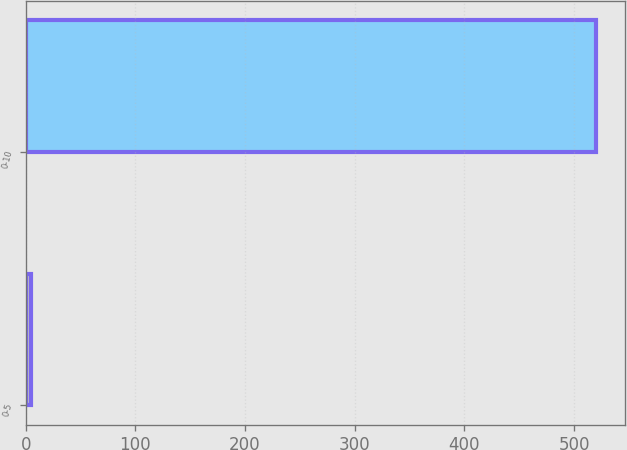Convert chart. <chart><loc_0><loc_0><loc_500><loc_500><bar_chart><fcel>0-5<fcel>0-10<nl><fcel>5<fcel>520<nl></chart> 